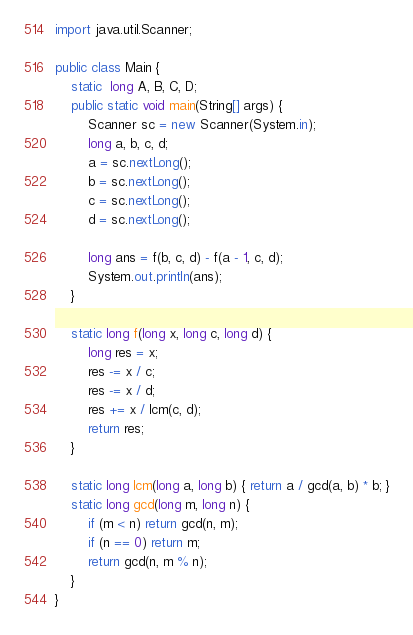<code> <loc_0><loc_0><loc_500><loc_500><_Java_>import java.util.Scanner;

public class Main {
	static  long A, B, C, D;
	public static void main(String[] args) {
		Scanner sc = new Scanner(System.in);
		long a, b, c, d;
		a = sc.nextLong();
		b = sc.nextLong();
		c = sc.nextLong();
		d = sc.nextLong();

		long ans = f(b, c, d) - f(a - 1, c, d);
		System.out.println(ans);
	}

	static long f(long x, long c, long d) {
		long res = x;
		res -= x / c;
		res -= x / d;
		res += x / lcm(c, d);
		return res;
	}

	static long lcm(long a, long b) { return a / gcd(a, b) * b; }
	static long gcd(long m, long n) {
		if (m < n) return gcd(n, m);
		if (n == 0) return m;
		return gcd(n, m % n);
	}
}</code> 